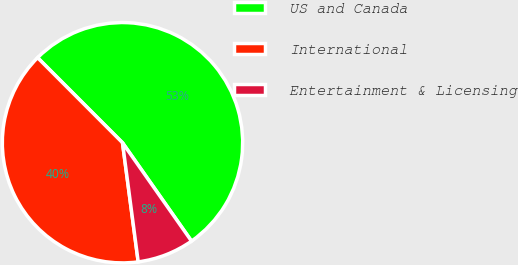<chart> <loc_0><loc_0><loc_500><loc_500><pie_chart><fcel>US and Canada<fcel>International<fcel>Entertainment & Licensing<nl><fcel>52.75%<fcel>39.6%<fcel>7.65%<nl></chart> 